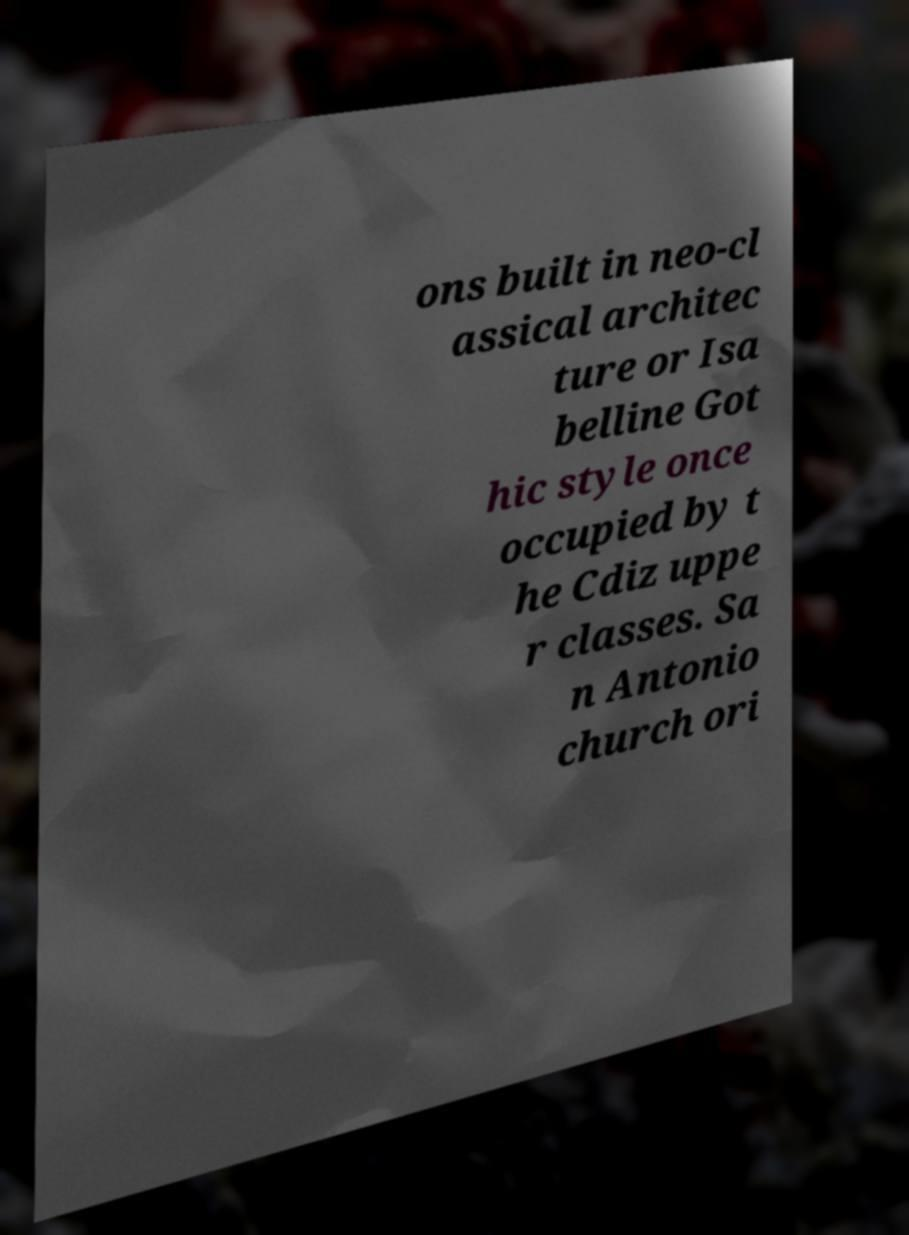Could you extract and type out the text from this image? ons built in neo-cl assical architec ture or Isa belline Got hic style once occupied by t he Cdiz uppe r classes. Sa n Antonio church ori 